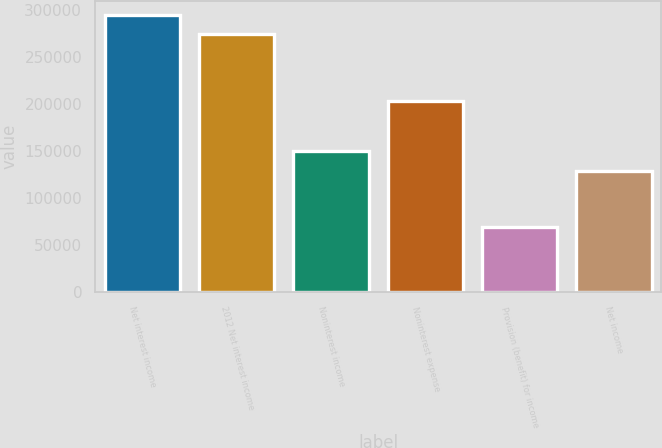Convert chart to OTSL. <chart><loc_0><loc_0><loc_500><loc_500><bar_chart><fcel>Net interest income<fcel>2012 Net interest income<fcel>Noninterest income<fcel>Noninterest expense<fcel>Provision (benefit) for income<fcel>Net income<nl><fcel>294565<fcel>273869<fcel>149808<fcel>203000<fcel>69522<fcel>129112<nl></chart> 